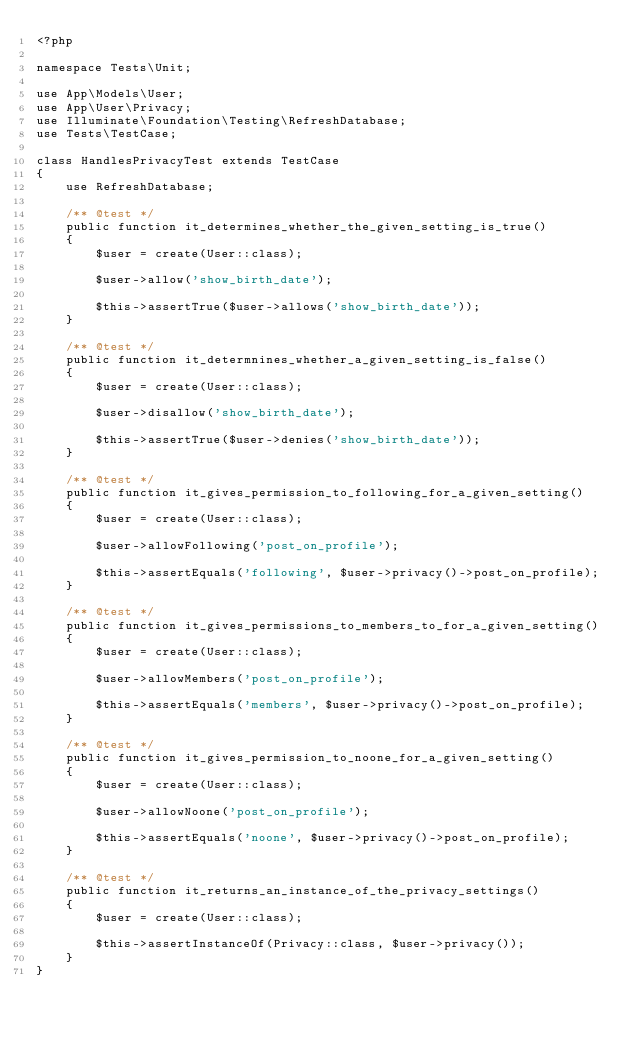Convert code to text. <code><loc_0><loc_0><loc_500><loc_500><_PHP_><?php

namespace Tests\Unit;

use App\Models\User;
use App\User\Privacy;
use Illuminate\Foundation\Testing\RefreshDatabase;
use Tests\TestCase;

class HandlesPrivacyTest extends TestCase
{
    use RefreshDatabase;

    /** @test */
    public function it_determines_whether_the_given_setting_is_true()
    {
        $user = create(User::class);

        $user->allow('show_birth_date');

        $this->assertTrue($user->allows('show_birth_date'));
    }

    /** @test */
    public function it_determnines_whether_a_given_setting_is_false()
    {
        $user = create(User::class);

        $user->disallow('show_birth_date');

        $this->assertTrue($user->denies('show_birth_date'));
    }

    /** @test */
    public function it_gives_permission_to_following_for_a_given_setting()
    {
        $user = create(User::class);

        $user->allowFollowing('post_on_profile');

        $this->assertEquals('following', $user->privacy()->post_on_profile);
    }

    /** @test */
    public function it_gives_permissions_to_members_to_for_a_given_setting()
    {
        $user = create(User::class);

        $user->allowMembers('post_on_profile');

        $this->assertEquals('members', $user->privacy()->post_on_profile);
    }

    /** @test */
    public function it_gives_permission_to_noone_for_a_given_setting()
    {
        $user = create(User::class);

        $user->allowNoone('post_on_profile');

        $this->assertEquals('noone', $user->privacy()->post_on_profile);
    }

    /** @test */
    public function it_returns_an_instance_of_the_privacy_settings()
    {
        $user = create(User::class);

        $this->assertInstanceOf(Privacy::class, $user->privacy());
    }
}</code> 